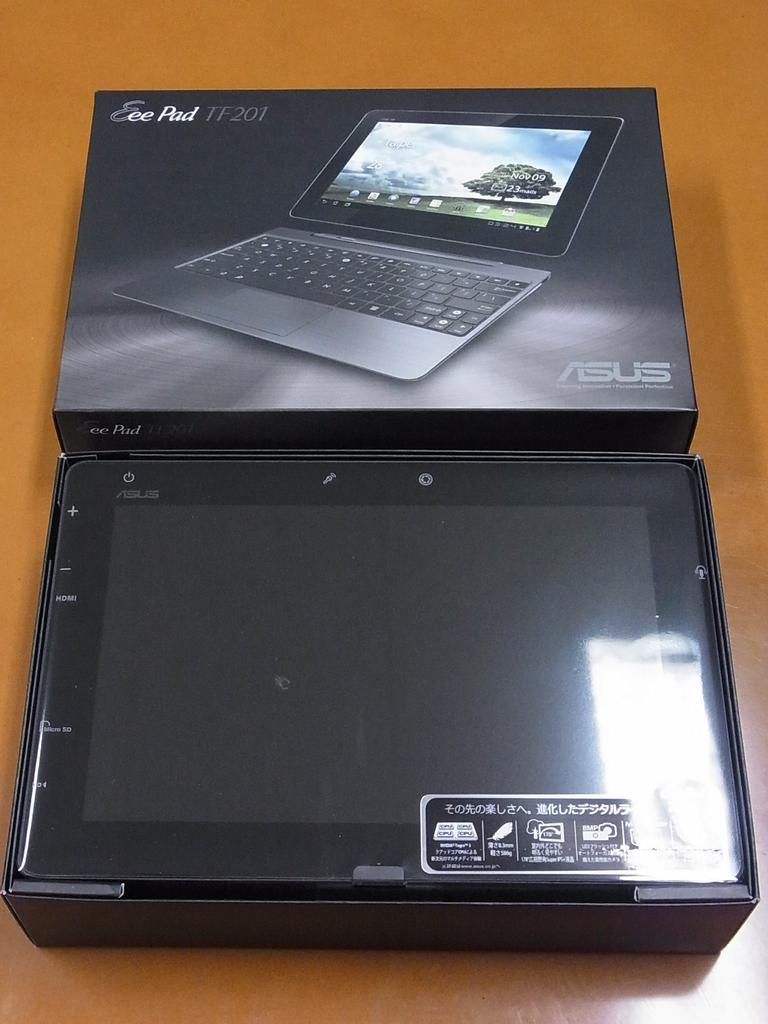What is inside the box that is visible in the image? There is a box containing a tablet in the image. Can you describe another object in the image? There is another box in the middle of the image. What type of needle can be seen on the seashore in the image? There is no needle or seashore present in the image; it only contains two boxes. 